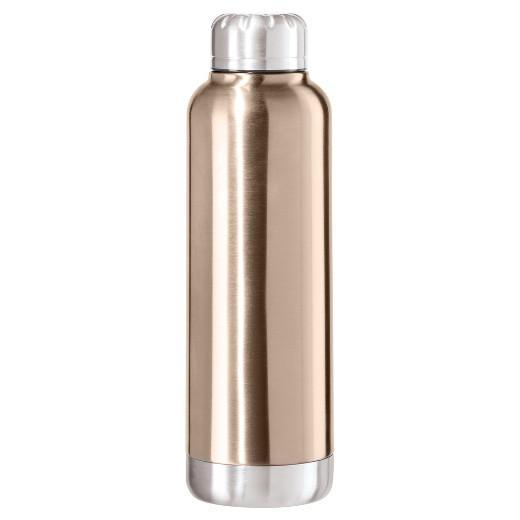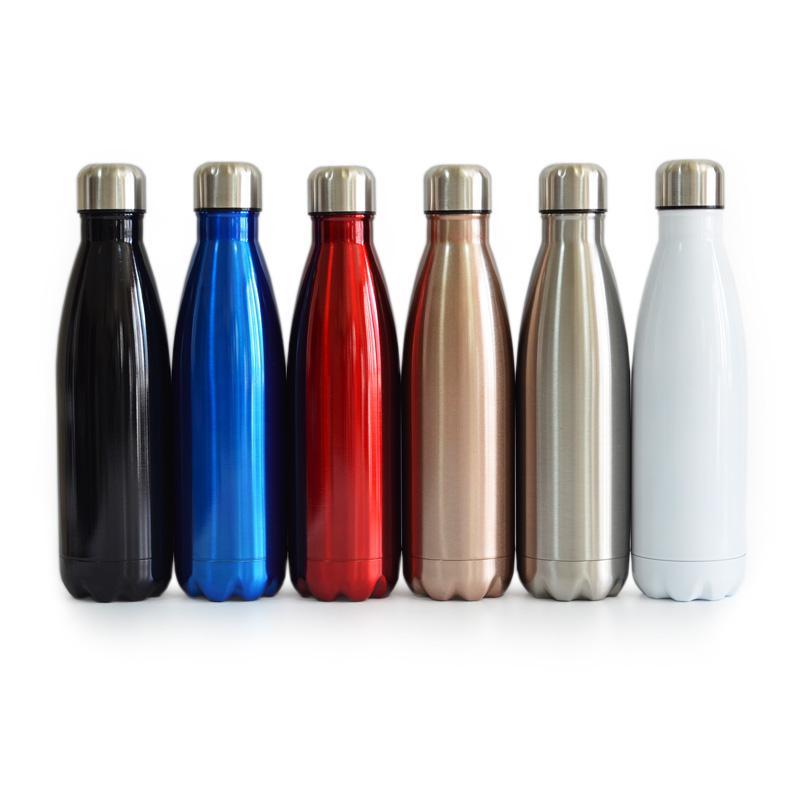The first image is the image on the left, the second image is the image on the right. Given the left and right images, does the statement "The left hand image contains a solo water bottle, while the left hand image contains a row or varying colored water bottles." hold true? Answer yes or no. Yes. 